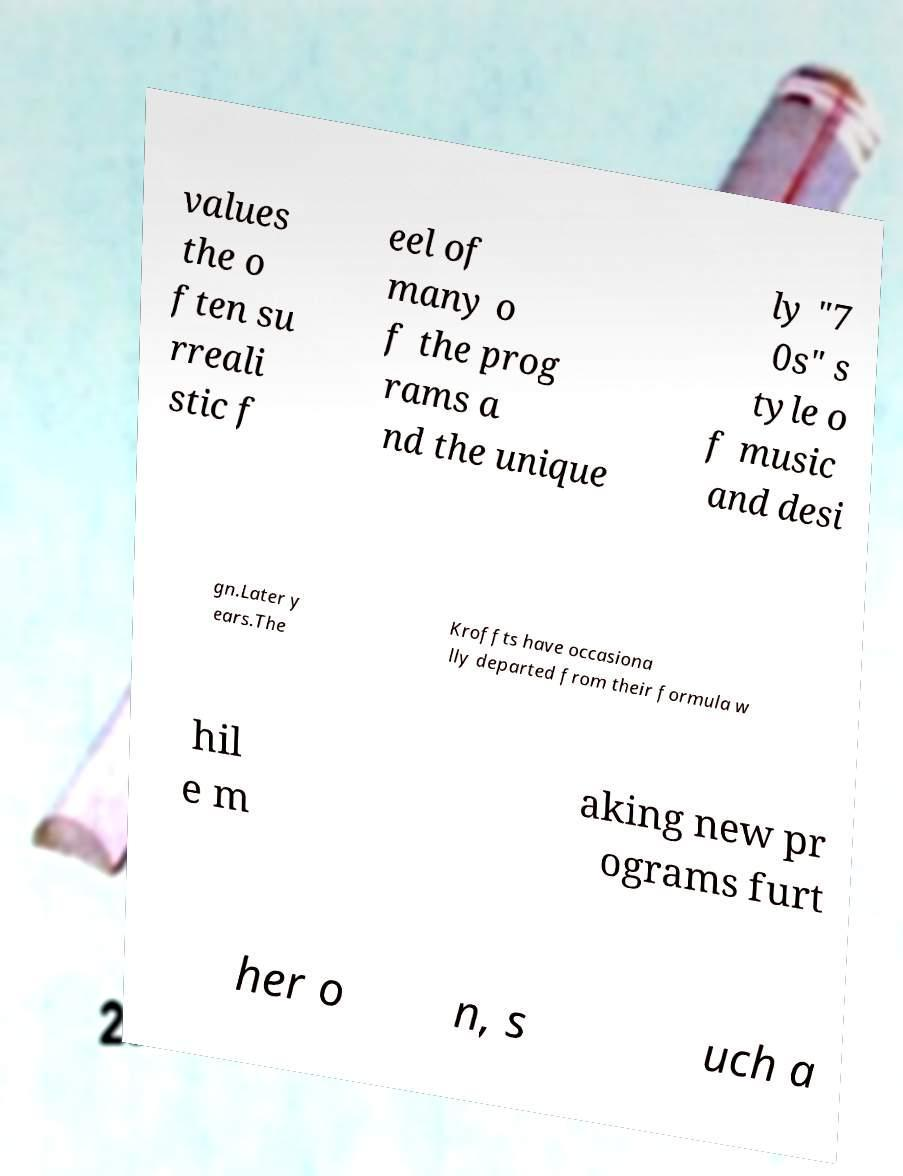What messages or text are displayed in this image? I need them in a readable, typed format. values the o ften su rreali stic f eel of many o f the prog rams a nd the unique ly "7 0s" s tyle o f music and desi gn.Later y ears.The Kroffts have occasiona lly departed from their formula w hil e m aking new pr ograms furt her o n, s uch a 